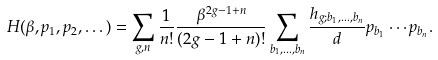Convert formula to latex. <formula><loc_0><loc_0><loc_500><loc_500>H ( \beta , p _ { 1 } , p _ { 2 } , \dots ) = \sum _ { g , n } \frac { 1 } { n ! } \frac { \beta ^ { 2 g - 1 + n } } { ( 2 g - 1 + n ) ! } \sum _ { b _ { 1 } , \dots , b _ { n } } \frac { h _ { g ; b _ { 1 } , \dots , b _ { n } } } { d } p _ { b _ { 1 } } \cdots p _ { b _ { n } } .</formula> 